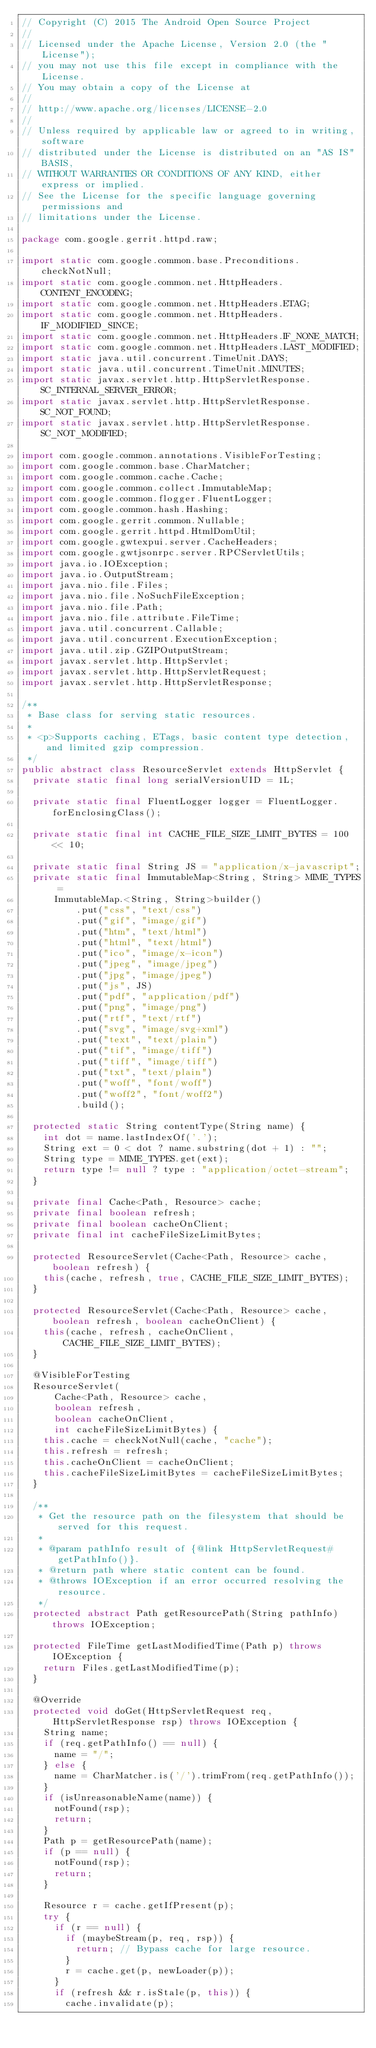<code> <loc_0><loc_0><loc_500><loc_500><_Java_>// Copyright (C) 2015 The Android Open Source Project
//
// Licensed under the Apache License, Version 2.0 (the "License");
// you may not use this file except in compliance with the License.
// You may obtain a copy of the License at
//
// http://www.apache.org/licenses/LICENSE-2.0
//
// Unless required by applicable law or agreed to in writing, software
// distributed under the License is distributed on an "AS IS" BASIS,
// WITHOUT WARRANTIES OR CONDITIONS OF ANY KIND, either express or implied.
// See the License for the specific language governing permissions and
// limitations under the License.

package com.google.gerrit.httpd.raw;

import static com.google.common.base.Preconditions.checkNotNull;
import static com.google.common.net.HttpHeaders.CONTENT_ENCODING;
import static com.google.common.net.HttpHeaders.ETAG;
import static com.google.common.net.HttpHeaders.IF_MODIFIED_SINCE;
import static com.google.common.net.HttpHeaders.IF_NONE_MATCH;
import static com.google.common.net.HttpHeaders.LAST_MODIFIED;
import static java.util.concurrent.TimeUnit.DAYS;
import static java.util.concurrent.TimeUnit.MINUTES;
import static javax.servlet.http.HttpServletResponse.SC_INTERNAL_SERVER_ERROR;
import static javax.servlet.http.HttpServletResponse.SC_NOT_FOUND;
import static javax.servlet.http.HttpServletResponse.SC_NOT_MODIFIED;

import com.google.common.annotations.VisibleForTesting;
import com.google.common.base.CharMatcher;
import com.google.common.cache.Cache;
import com.google.common.collect.ImmutableMap;
import com.google.common.flogger.FluentLogger;
import com.google.common.hash.Hashing;
import com.google.gerrit.common.Nullable;
import com.google.gerrit.httpd.HtmlDomUtil;
import com.google.gwtexpui.server.CacheHeaders;
import com.google.gwtjsonrpc.server.RPCServletUtils;
import java.io.IOException;
import java.io.OutputStream;
import java.nio.file.Files;
import java.nio.file.NoSuchFileException;
import java.nio.file.Path;
import java.nio.file.attribute.FileTime;
import java.util.concurrent.Callable;
import java.util.concurrent.ExecutionException;
import java.util.zip.GZIPOutputStream;
import javax.servlet.http.HttpServlet;
import javax.servlet.http.HttpServletRequest;
import javax.servlet.http.HttpServletResponse;

/**
 * Base class for serving static resources.
 *
 * <p>Supports caching, ETags, basic content type detection, and limited gzip compression.
 */
public abstract class ResourceServlet extends HttpServlet {
  private static final long serialVersionUID = 1L;

  private static final FluentLogger logger = FluentLogger.forEnclosingClass();

  private static final int CACHE_FILE_SIZE_LIMIT_BYTES = 100 << 10;

  private static final String JS = "application/x-javascript";
  private static final ImmutableMap<String, String> MIME_TYPES =
      ImmutableMap.<String, String>builder()
          .put("css", "text/css")
          .put("gif", "image/gif")
          .put("htm", "text/html")
          .put("html", "text/html")
          .put("ico", "image/x-icon")
          .put("jpeg", "image/jpeg")
          .put("jpg", "image/jpeg")
          .put("js", JS)
          .put("pdf", "application/pdf")
          .put("png", "image/png")
          .put("rtf", "text/rtf")
          .put("svg", "image/svg+xml")
          .put("text", "text/plain")
          .put("tif", "image/tiff")
          .put("tiff", "image/tiff")
          .put("txt", "text/plain")
          .put("woff", "font/woff")
          .put("woff2", "font/woff2")
          .build();

  protected static String contentType(String name) {
    int dot = name.lastIndexOf('.');
    String ext = 0 < dot ? name.substring(dot + 1) : "";
    String type = MIME_TYPES.get(ext);
    return type != null ? type : "application/octet-stream";
  }

  private final Cache<Path, Resource> cache;
  private final boolean refresh;
  private final boolean cacheOnClient;
  private final int cacheFileSizeLimitBytes;

  protected ResourceServlet(Cache<Path, Resource> cache, boolean refresh) {
    this(cache, refresh, true, CACHE_FILE_SIZE_LIMIT_BYTES);
  }

  protected ResourceServlet(Cache<Path, Resource> cache, boolean refresh, boolean cacheOnClient) {
    this(cache, refresh, cacheOnClient, CACHE_FILE_SIZE_LIMIT_BYTES);
  }

  @VisibleForTesting
  ResourceServlet(
      Cache<Path, Resource> cache,
      boolean refresh,
      boolean cacheOnClient,
      int cacheFileSizeLimitBytes) {
    this.cache = checkNotNull(cache, "cache");
    this.refresh = refresh;
    this.cacheOnClient = cacheOnClient;
    this.cacheFileSizeLimitBytes = cacheFileSizeLimitBytes;
  }

  /**
   * Get the resource path on the filesystem that should be served for this request.
   *
   * @param pathInfo result of {@link HttpServletRequest#getPathInfo()}.
   * @return path where static content can be found.
   * @throws IOException if an error occurred resolving the resource.
   */
  protected abstract Path getResourcePath(String pathInfo) throws IOException;

  protected FileTime getLastModifiedTime(Path p) throws IOException {
    return Files.getLastModifiedTime(p);
  }

  @Override
  protected void doGet(HttpServletRequest req, HttpServletResponse rsp) throws IOException {
    String name;
    if (req.getPathInfo() == null) {
      name = "/";
    } else {
      name = CharMatcher.is('/').trimFrom(req.getPathInfo());
    }
    if (isUnreasonableName(name)) {
      notFound(rsp);
      return;
    }
    Path p = getResourcePath(name);
    if (p == null) {
      notFound(rsp);
      return;
    }

    Resource r = cache.getIfPresent(p);
    try {
      if (r == null) {
        if (maybeStream(p, req, rsp)) {
          return; // Bypass cache for large resource.
        }
        r = cache.get(p, newLoader(p));
      }
      if (refresh && r.isStale(p, this)) {
        cache.invalidate(p);</code> 